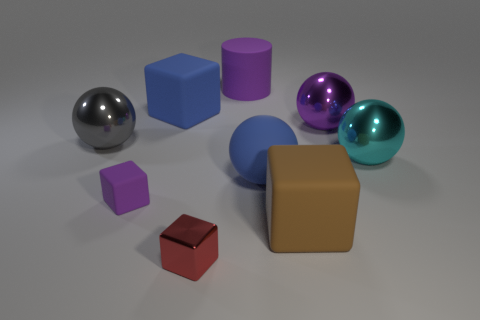Subtract all big purple spheres. How many spheres are left? 3 Subtract 2 balls. How many balls are left? 2 Subtract all red cubes. How many cubes are left? 3 Subtract all yellow cubes. Subtract all brown balls. How many cubes are left? 4 Add 1 small cubes. How many objects exist? 10 Subtract all spheres. How many objects are left? 5 Subtract all cyan balls. Subtract all big purple cylinders. How many objects are left? 7 Add 7 big cubes. How many big cubes are left? 9 Add 9 large yellow rubber cylinders. How many large yellow rubber cylinders exist? 9 Subtract 0 red spheres. How many objects are left? 9 